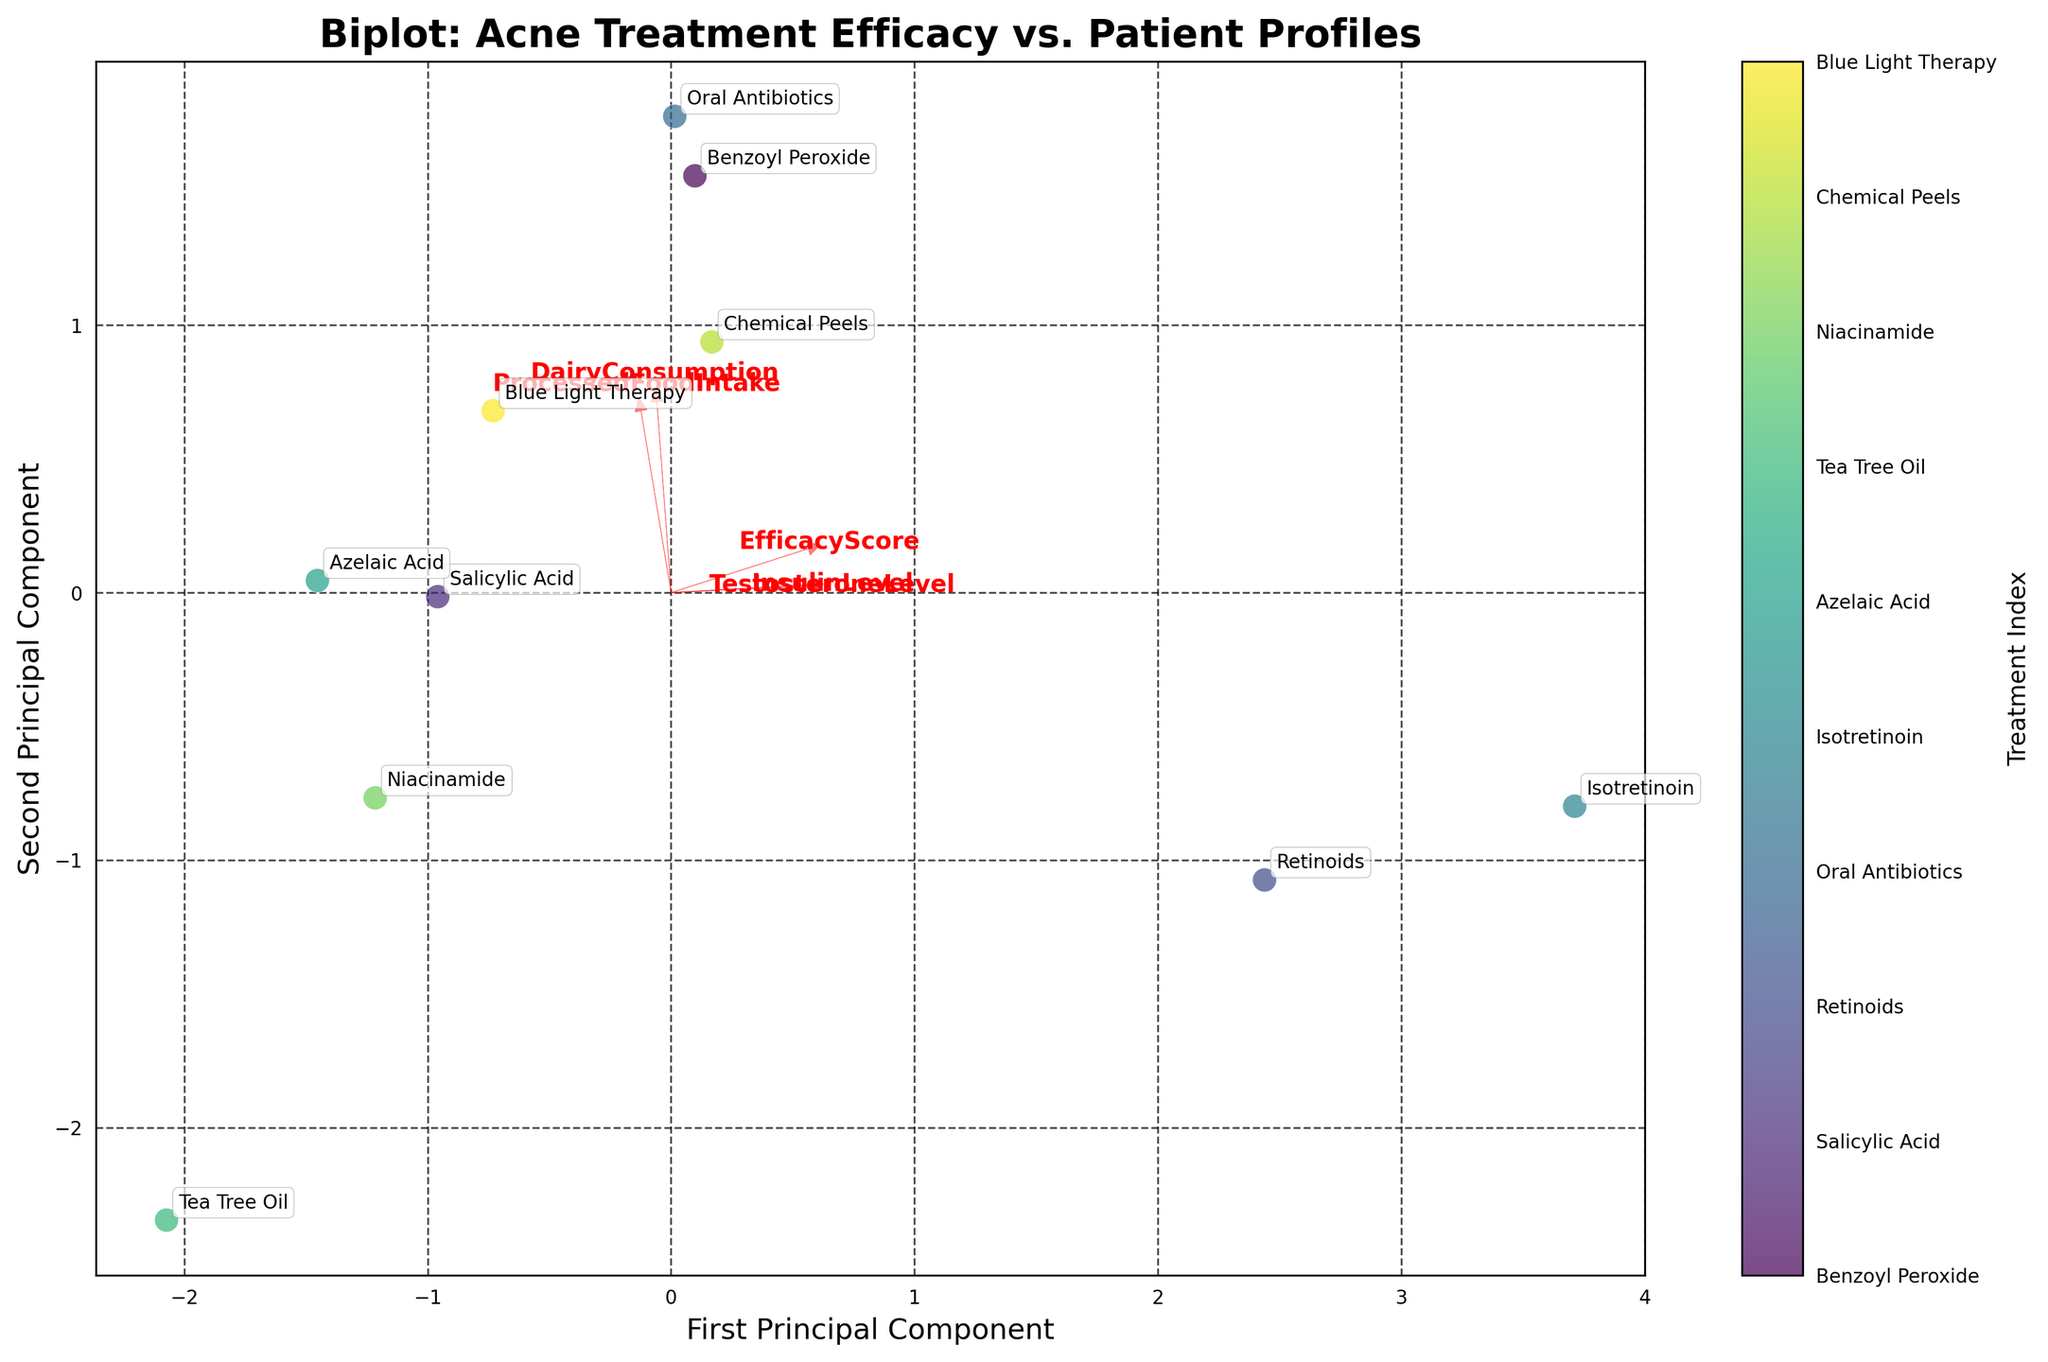What is the title of the figure? The title is usually found at the top of the figure, indicating the main topic or focus of the visualization. Here, it specifies the context—acne treatment efficacy and patient profiles.
Answer: Biplot: Acne Treatment Efficacy vs. Patient Profiles How many treatments are compared in the biplot? Count the number of unique treatments labeled in the figure. Each treatment corresponds to a data point on the plot.
Answer: 10 Which acne treatment shows the highest efficacy score according to the biplot? Locate the data points on the plot and refer to the color bar or the treatment labels to find the one with the highest EfficacyScore.
Answer: Isotretinoin What are the labels on the axes? Examine the x-axis and y-axis labels to identify what each principal component represents.
Answer: First Principal Component (x-axis), Second Principal Component (y-axis) Which feature vector has the longest arrow on the biplot? Observe the length of each red arrow representing the different features. The longest one indicates the feature with the highest loading on the principal components.
Answer: TestosteroneLevel What is the relationship between DairyConsumption and ProcessedFoodIntake in the biplot? Look at the direction and proximity of the arrows for DairyConsumption and ProcessedFoodIntake to deduce their correlation.
Answer: Strong positive correlation Which treatment appears closest to the origin of the biplot? Identify the data point that is nearest to the (0, 0) position on the plot, which usually indicates a neutral profile in terms of principal component scores.
Answer: Tea Tree Oil How does TestosteroneLevel influence the treatments clustered together in the upper right quadrant of the biplot? Analyze the directions of the arrows for the features and the data points in the upper right quadrant to infer the influence.
Answer: Higher values Do the treatments with higher EfficacyScores tend to align with higher or lower InsulinLevels? Examine the direction of the arrow for InsulinLevel and correlate it with the position of treatments having higher EfficacyScores.
Answer: Higher InsulinLevels Which two features have the most orthogonal (least correlated) relationship in the biplot? Look for pairs of arrows that form the closest to a 90-degree angle with each other, which implies little to no correlation.
Answer: DairyConsumption and TestosteroneLevel 